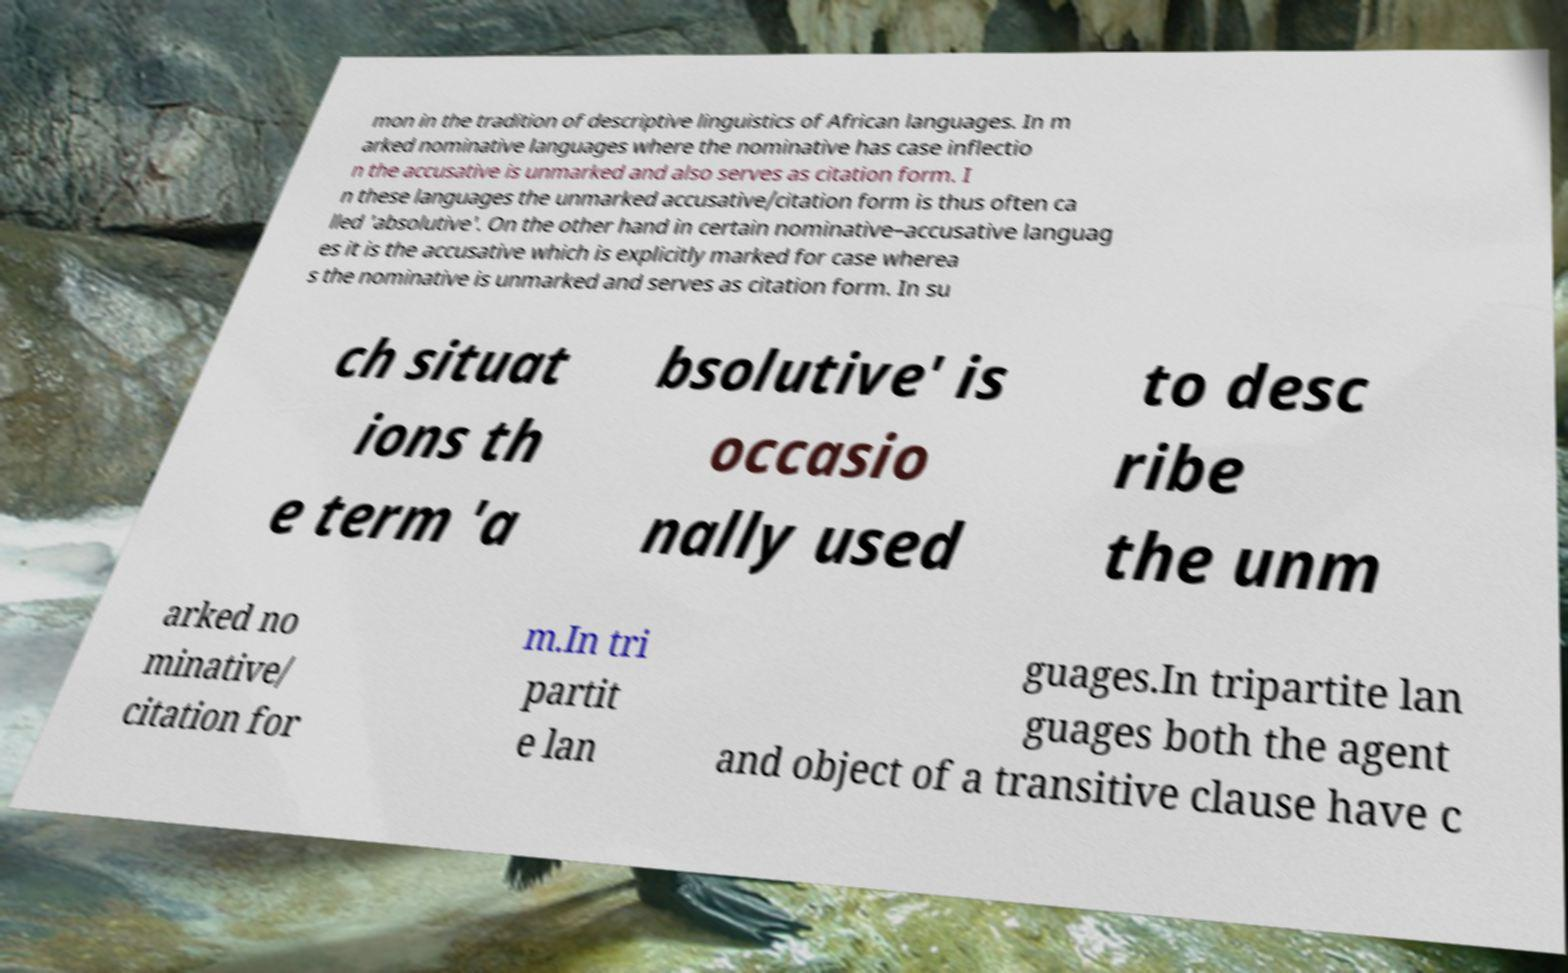There's text embedded in this image that I need extracted. Can you transcribe it verbatim? mon in the tradition of descriptive linguistics of African languages. In m arked nominative languages where the nominative has case inflectio n the accusative is unmarked and also serves as citation form. I n these languages the unmarked accusative/citation form is thus often ca lled 'absolutive'. On the other hand in certain nominative–accusative languag es it is the accusative which is explicitly marked for case wherea s the nominative is unmarked and serves as citation form. In su ch situat ions th e term 'a bsolutive' is occasio nally used to desc ribe the unm arked no minative/ citation for m.In tri partit e lan guages.In tripartite lan guages both the agent and object of a transitive clause have c 